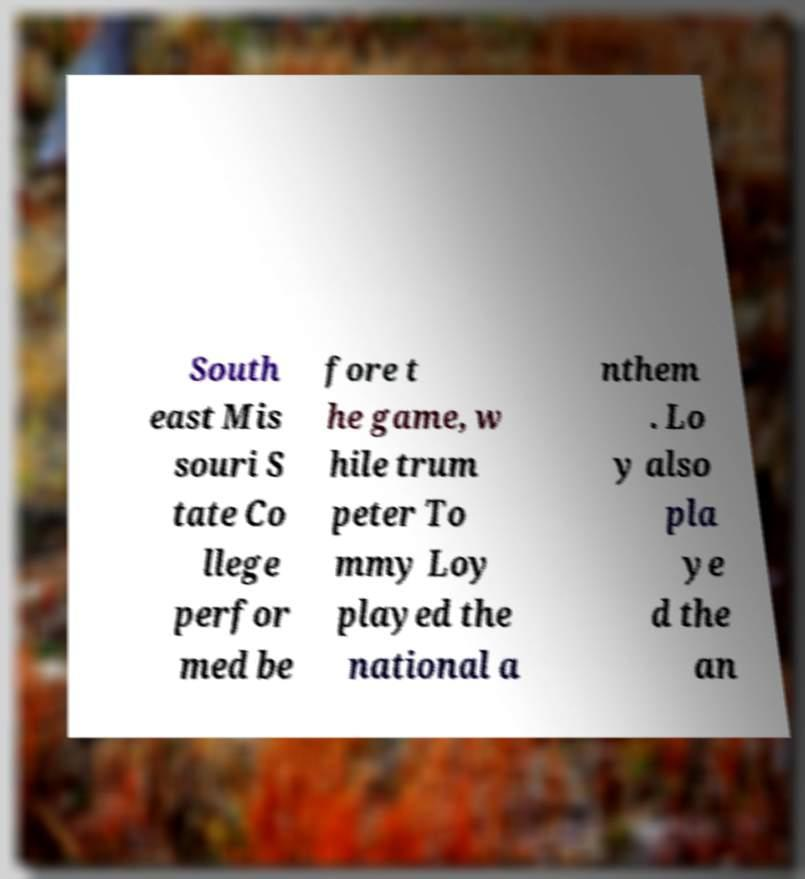Please read and relay the text visible in this image. What does it say? South east Mis souri S tate Co llege perfor med be fore t he game, w hile trum peter To mmy Loy played the national a nthem . Lo y also pla ye d the an 